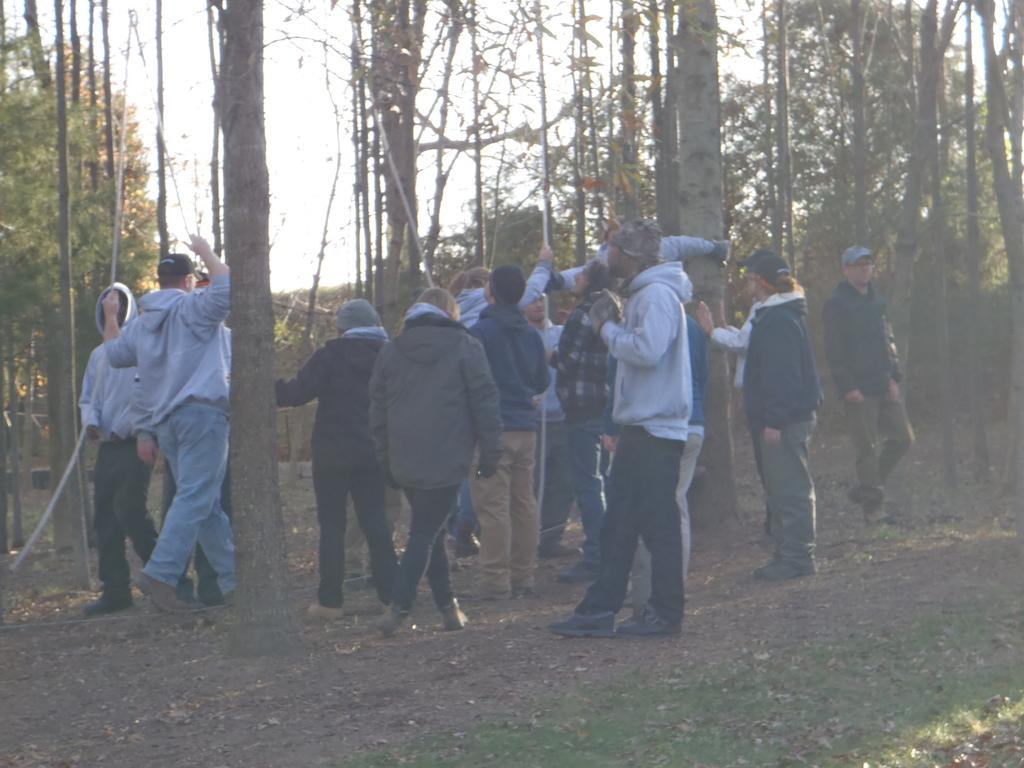How many people are in the image? There is a group of people in the image. What are the people doing in the image? The people are standing on the ground. What is one person holding in his hand? One person is holding a rope in his hand. What can be seen on the person holding the rope? The person holding the rope is wearing a black cap. What is visible in the background of the image? There is a group of trees and the sky in the background of the image. What statement is being made by the children in the image? There are no children present in the image, and no statements can be observed. 